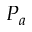<formula> <loc_0><loc_0><loc_500><loc_500>P _ { a }</formula> 